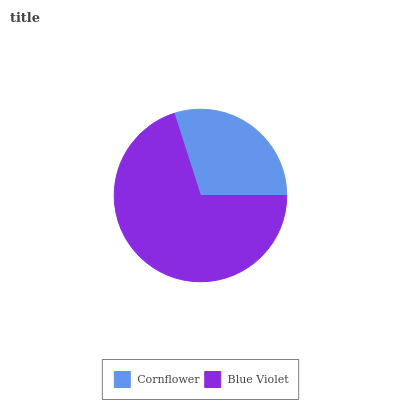Is Cornflower the minimum?
Answer yes or no. Yes. Is Blue Violet the maximum?
Answer yes or no. Yes. Is Blue Violet the minimum?
Answer yes or no. No. Is Blue Violet greater than Cornflower?
Answer yes or no. Yes. Is Cornflower less than Blue Violet?
Answer yes or no. Yes. Is Cornflower greater than Blue Violet?
Answer yes or no. No. Is Blue Violet less than Cornflower?
Answer yes or no. No. Is Blue Violet the high median?
Answer yes or no. Yes. Is Cornflower the low median?
Answer yes or no. Yes. Is Cornflower the high median?
Answer yes or no. No. Is Blue Violet the low median?
Answer yes or no. No. 